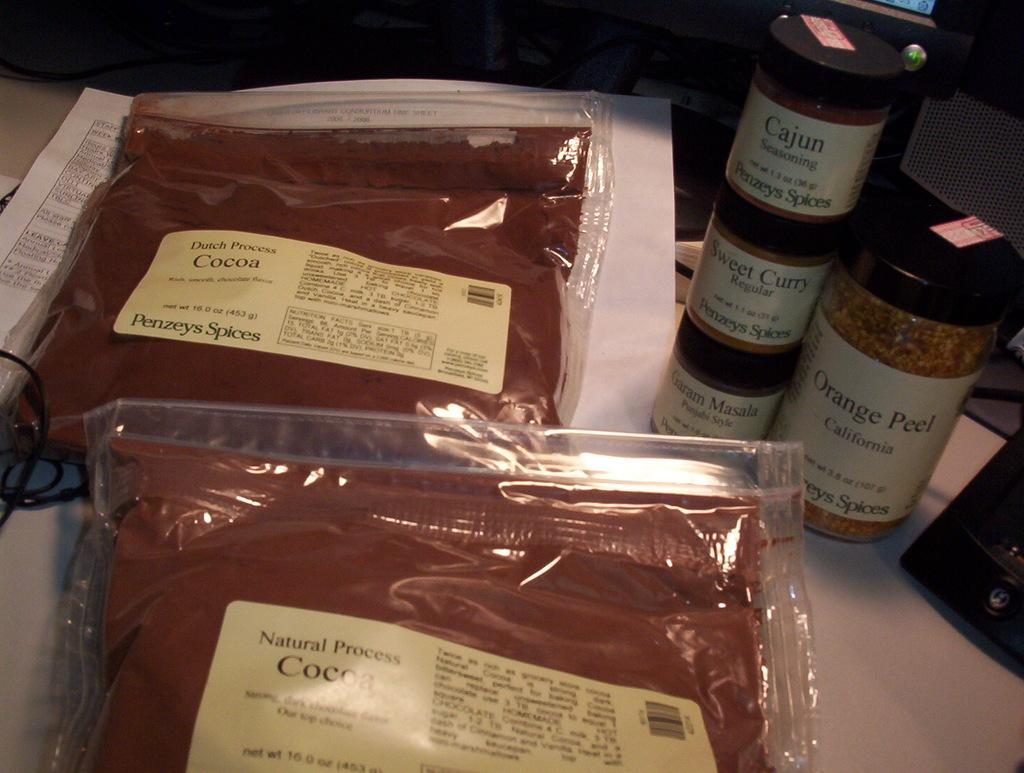<image>
Summarize the visual content of the image. Two plastic bags of natural process cocoa are next to a few bottles of other spices. 